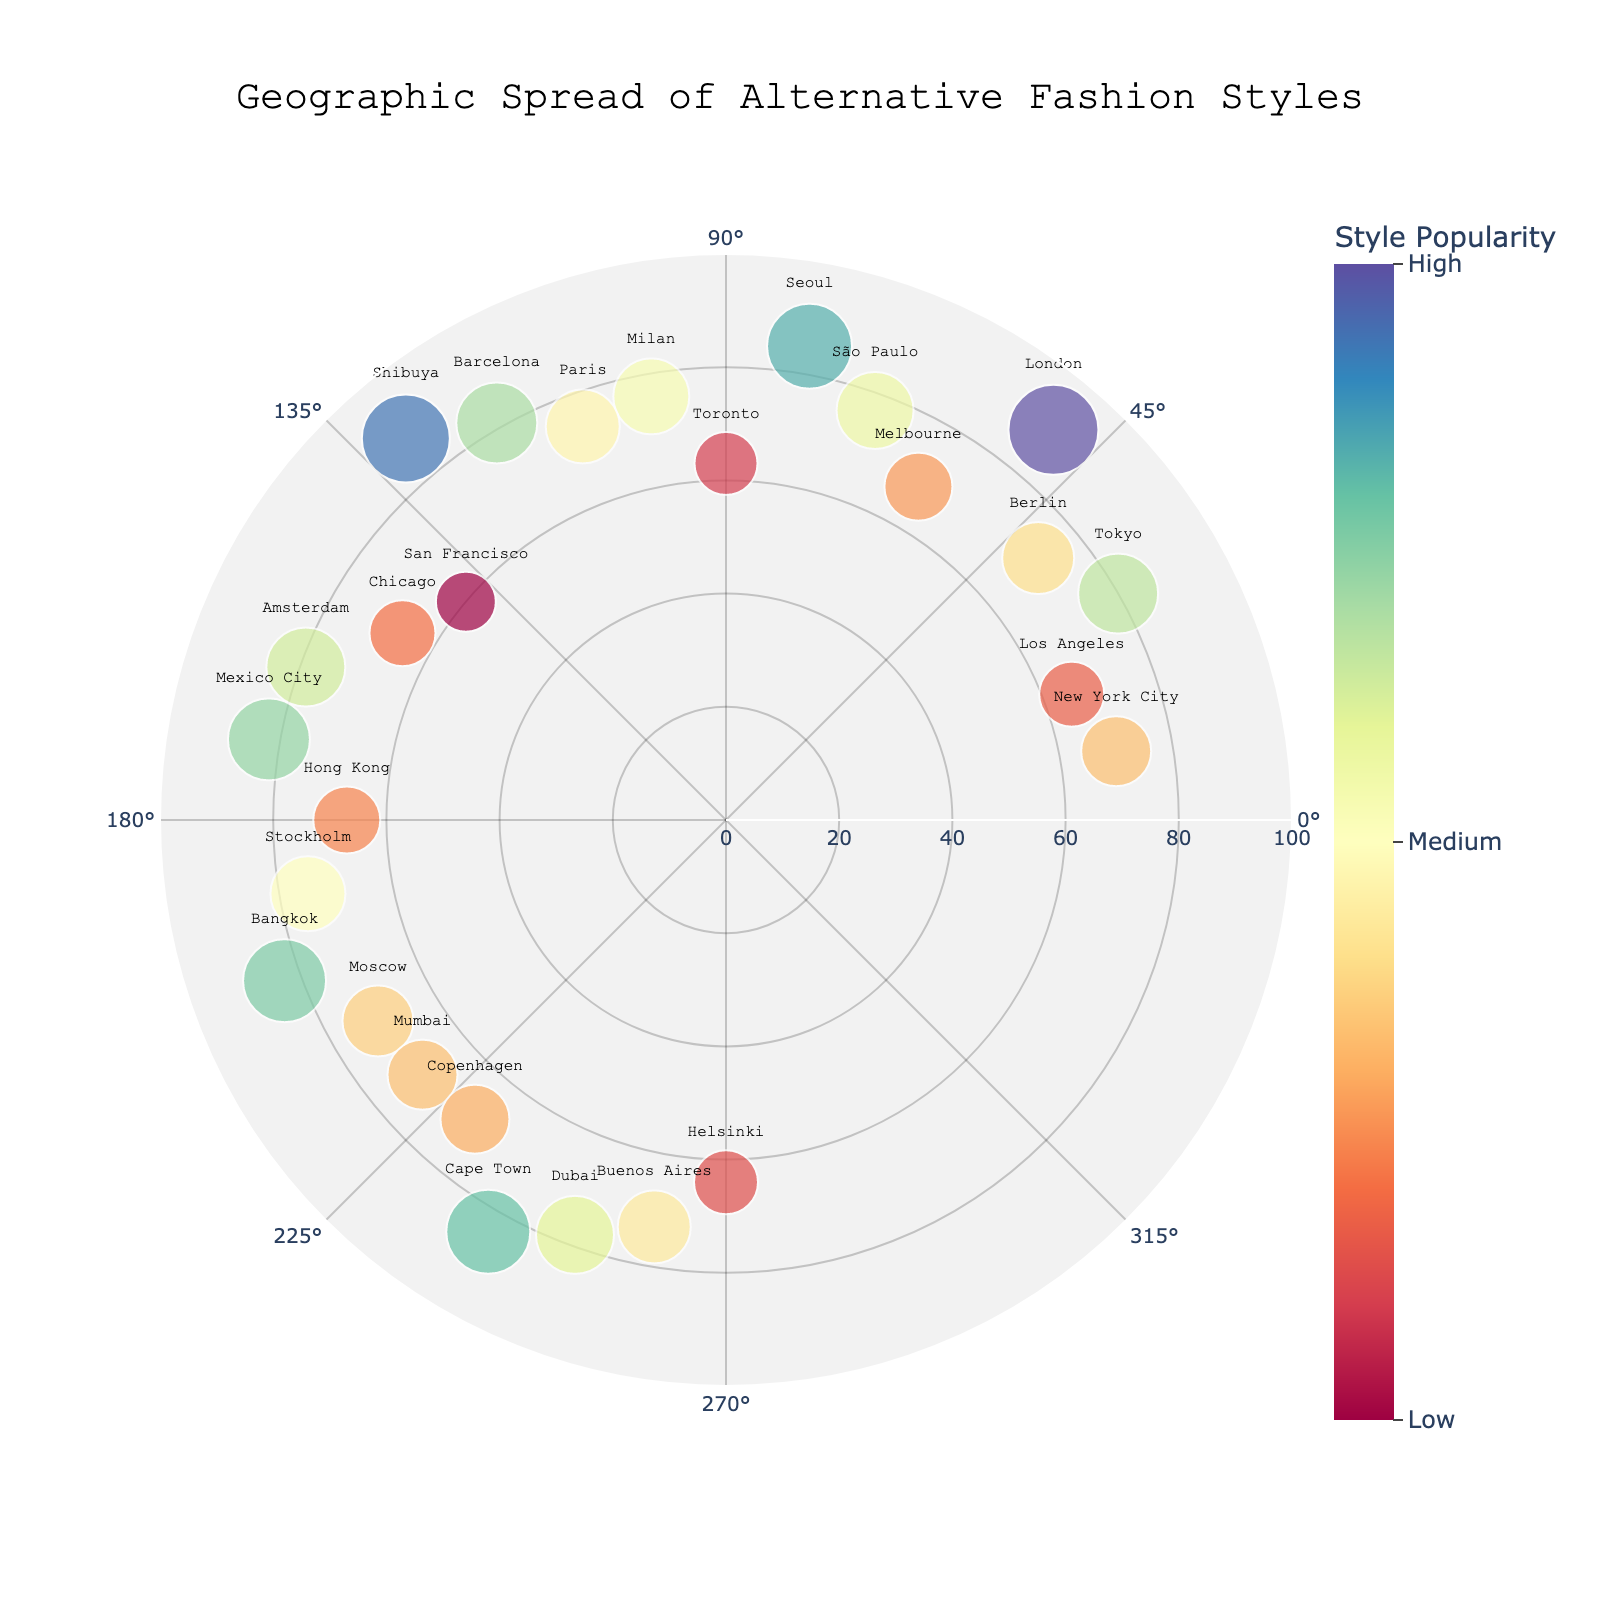Which location has the highest Radius (indicating the highest Style Popularity)? To determine this, look for the marker that extends the farthest from the center. The location text will help identify it.
Answer: London What is the approximate Style Popularity for the most popular style in Seoul? Find the marker for Seoul and check the radius and color. The radius is around 85, which the color scale indicates is High Populartiy.
Answer: 85 Which locations have a Punk fashion style according to the figure? Check the hovertext or legend associated with markers to identify those labeled "Punk". These markers at New York City and London.
Answer: New York City, London Is Punk more popular in New York City or London? Compare the radius of the markers for both locations. London's marker has a higher radius than New York City's.
Answer: London What are the Style Popularity values for Berlin and Tokyo? Identify the markers for Berlin and Tokyo and refer to their radius values. Tokyo has a radius of 80 and Berlin has a radius of 72.
Answer: Berlin: 72, Tokyo: 80 How many data points fall into the "High" popularity (radius above 75)? Count the markers with radii above 75. These are Tokyo, London, São Paulo, Seoul, Barcelona, Shibuya, Mexico City, Bangkok, and Cape Town.
Answer: 9 What is the commonality between the markers for Milan and Dubai? Both have mid-range popularity radii between 75 and 80 and their styles both incorporate an element of luxury or high fashion. Milan (High Fashion Punk) and Dubai (Luxury Streetwear).
Answer: Mid-range popularity, luxurious elements How does the popularity in Shibuya compare to that in Seoul? Both have high radii, but Shibuya's radius (88) is slightly higher than Seoul's radius (85).
Answer: Shibuya is slightly higher Which location has the lowest Style Popularity? Find the marker with the smallest radius. The smallest radius is for San Francisco with a radius of 60.
Answer: San Francisco What's the average Radius (Style Popularity) for all data points in this chart? Sum all the radius values (70 + 65 + 80 + 72 + 90 + 68 + 77 + 85 + 63 + 76 + 74 + 81 + 88 + 60 + 66 + 79 + 82 + 67 + 75 + 83 + 71 + 70 + 69 + 84 + 78 + 73 + 64) = 1957. There are 27 data points, so the average is 1957/27 ≈ 72.5.
Answer: 72.5 